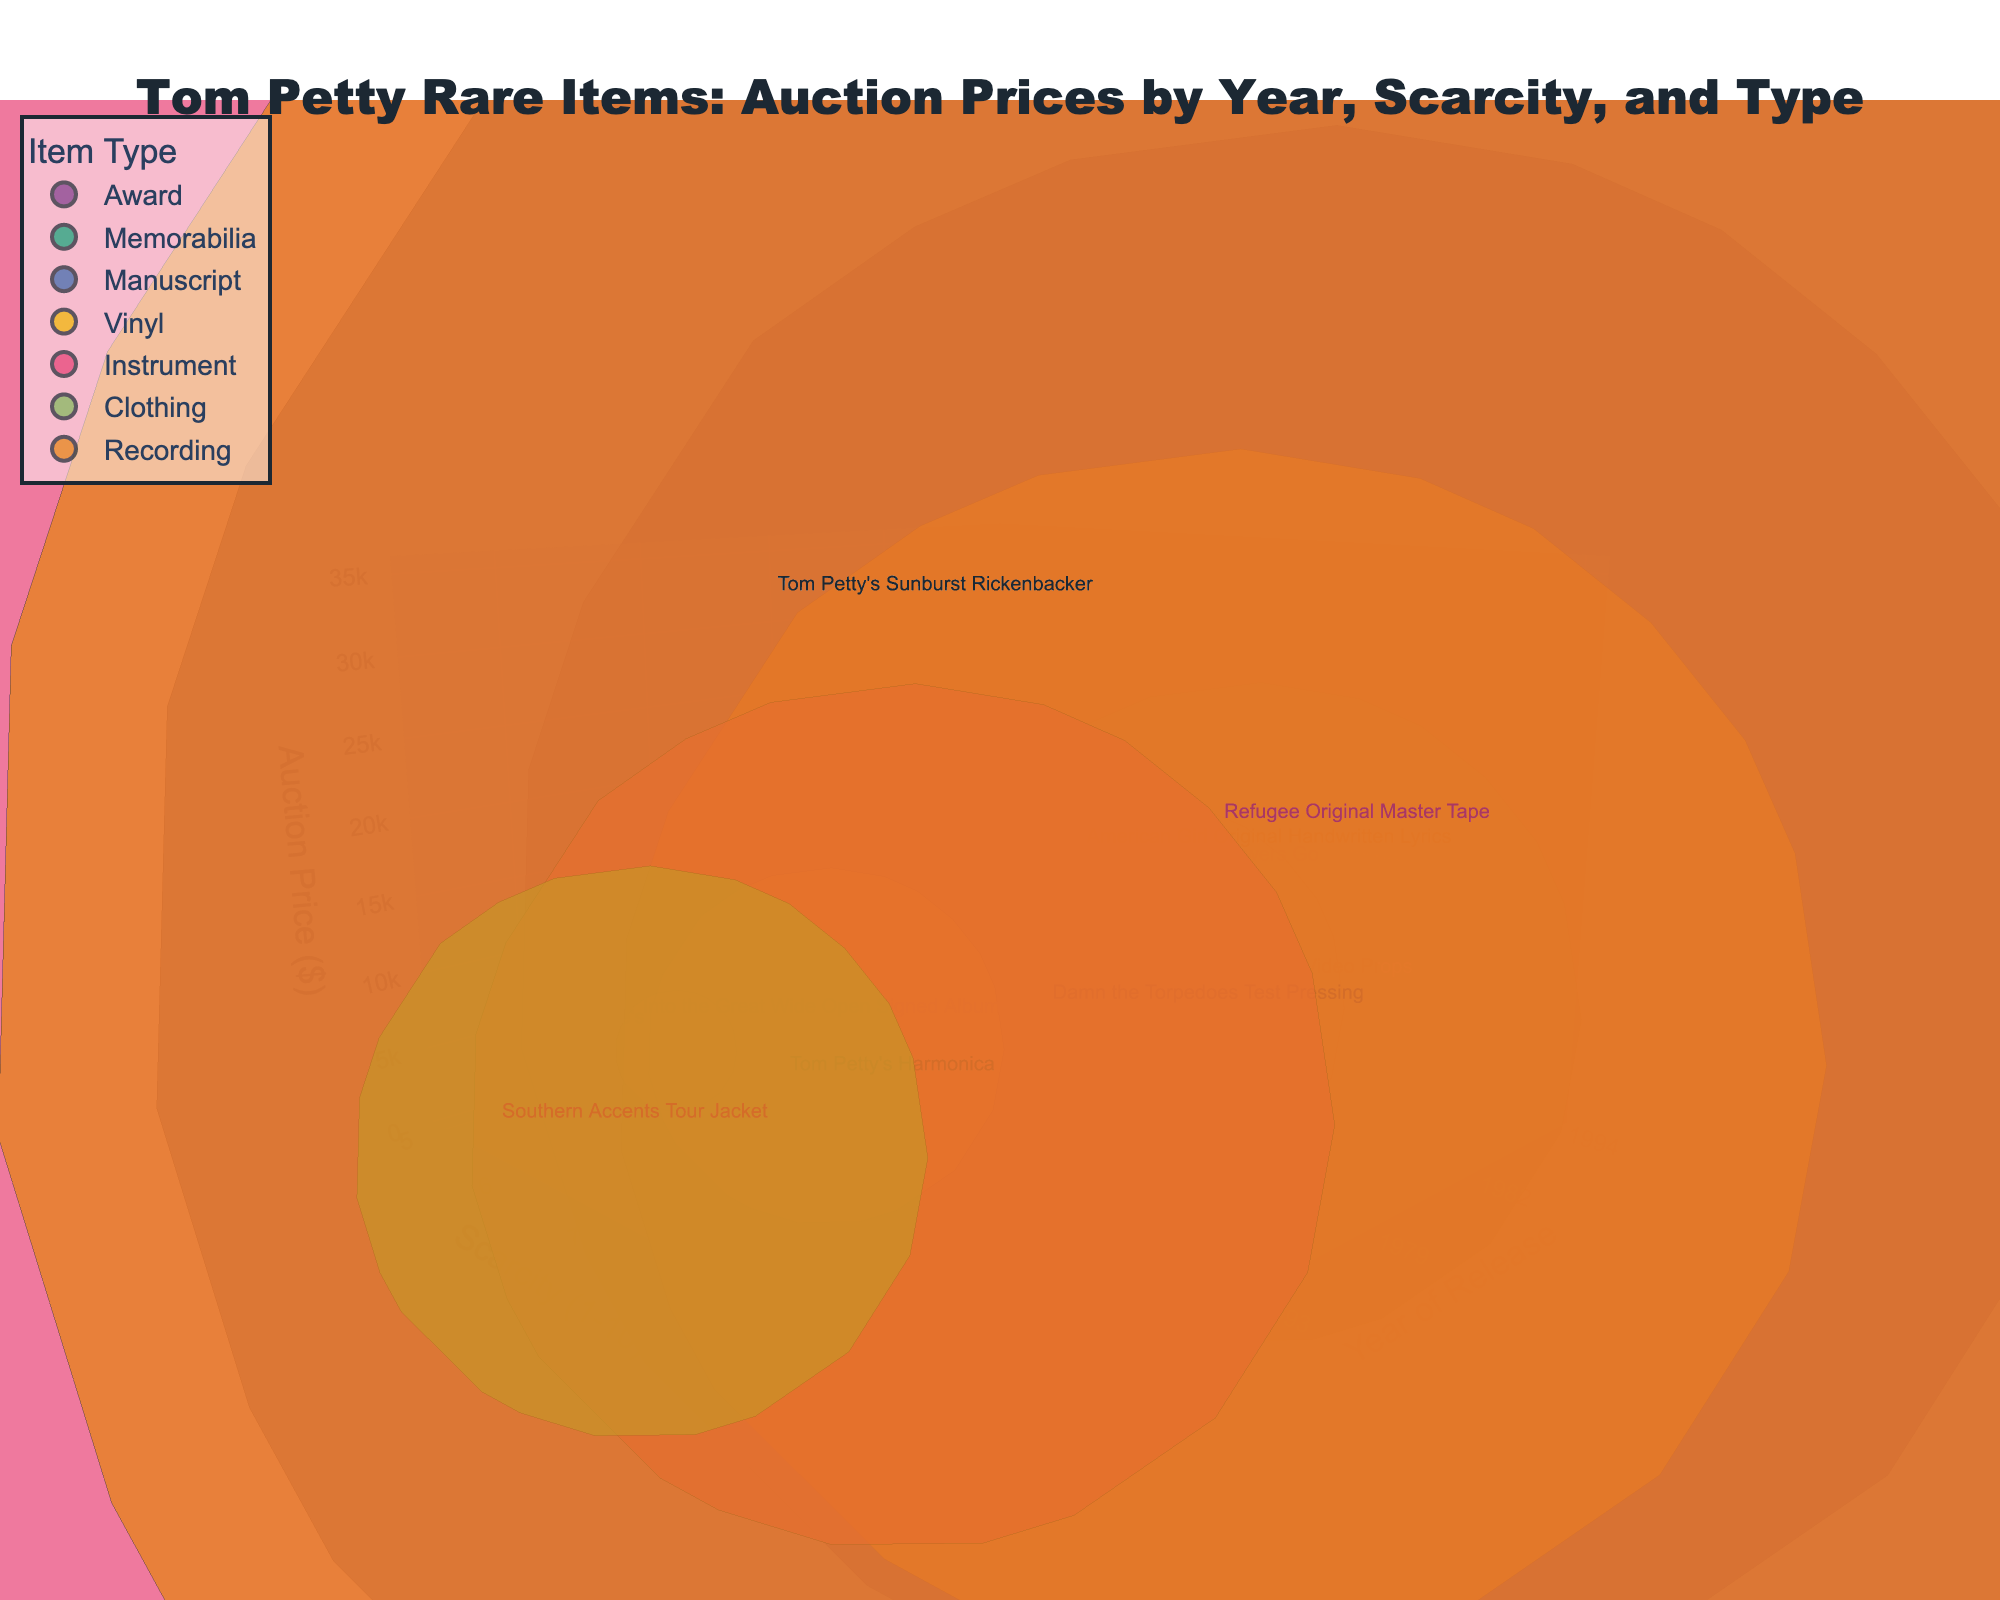How many different types of Tom Petty items are shown in the chart? By looking at the color legend, we can see the distinct types of items classified. Each color represents a different type.
Answer: 6 Which item has the highest auction price, and what is it? To find the highest auction price, look along the z-axis to see which point is farthest. Hover over that point to see the item name.
Answer: Tom Petty's Sunburst Rickenbacker Compare the scarcity levels of the "Wildflowers" Gold Record and "American Girl" Original Handwritten Lyrics. Which one is scarcer? Check the y-axis values for both items by hovering over their respective bubbles and comparing their positions on the y-axis.
Answer: "American Girl" Original Handwritten Lyrics What is the difference in auction prices between the "Refugee" Original Master Tape and Tom Petty's Harmonica? Identify the z-axis values (auction prices) for both items. Subtract the auction price of Tom Petty's Harmonica from that of the "Refugee" Original Master Tape.
Answer: 15,200 What is the most recent item on the chart based on the year of release, and what year was it released? Check along the x-axis for the highest year value and hover over the corresponding bubble to identify the item.
Answer: "Wildflowers" Gold Record, 1994 Is there any item from the 1980s that is both scarcer and priced higher compared to the "Southern Accents" Tour Jacket? If so, what item is it? Look at the bubbles from the 1980s on the x-axis, and compare both the scarcity and auction price values on their respective axes to those of the "Southern Accents" Tour Jacket.
Answer: "I Won't Back Down" Music Video Props Calculate the average scarcity of all Tom Petty items listed. Sum all the scarcity values and divide by the number of items. The scarcity values are: 8, 7, 9, 9, 8, 6, 7, 8, 10, 9, 6, 5. The sum is 92. The total number of items is 12. Therefore, the average scarcity is 92/12.
Answer: 7.67 Considering only "Manuscript" and "Vinyl" items, which type has the higher average auction price? Identify and sum up the auction prices for "Manuscript" and "Vinyl" items, then divide each sum by the number of items in each type and compare the averages. Manuscript: $18,000. Vinyl: $9,500 + $2,800 + $950 = $13,250. Average for Manuscript: $18,000 / 1 = $18,000. Average for Vinyl: $13,250 / 3 = $4,416.67. Manuscript has a higher average.
Answer: Manuscript What is the total auction price for all items released in 1979? Locate items with the year 1979 and sum their auction prices. The items are "Damn the Torpedoes" Test Pressing ($9,500) and "Refugee" Original Master Tape ($22,000). Thus, $9,500 + $22,000 = $31,500.
Answer: $31,500 